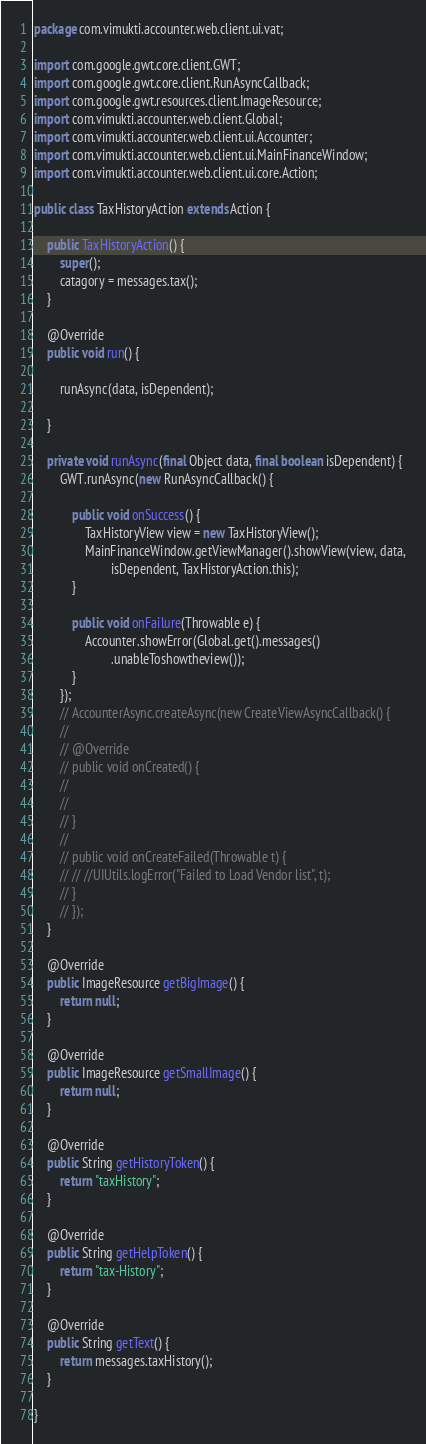<code> <loc_0><loc_0><loc_500><loc_500><_Java_>package com.vimukti.accounter.web.client.ui.vat;

import com.google.gwt.core.client.GWT;
import com.google.gwt.core.client.RunAsyncCallback;
import com.google.gwt.resources.client.ImageResource;
import com.vimukti.accounter.web.client.Global;
import com.vimukti.accounter.web.client.ui.Accounter;
import com.vimukti.accounter.web.client.ui.MainFinanceWindow;
import com.vimukti.accounter.web.client.ui.core.Action;

public class TaxHistoryAction extends Action {

	public TaxHistoryAction() {
		super();
		catagory = messages.tax();
	}

	@Override
	public void run() {

		runAsync(data, isDependent);

	}

	private void runAsync(final Object data, final boolean isDependent) {
		GWT.runAsync(new RunAsyncCallback() {

			public void onSuccess() {
				TaxHistoryView view = new TaxHistoryView();
				MainFinanceWindow.getViewManager().showView(view, data,
						isDependent, TaxHistoryAction.this);
			}

			public void onFailure(Throwable e) {
				Accounter.showError(Global.get().messages()
						.unableToshowtheview());
			}
		});
		// AccounterAsync.createAsync(new CreateViewAsyncCallback() {
		//
		// @Override
		// public void onCreated() {
		//
		//
		// }
		//
		// public void onCreateFailed(Throwable t) {
		// // //UIUtils.logError("Failed to Load Vendor list", t);
		// }
		// });
	}

	@Override
	public ImageResource getBigImage() {
		return null;
	}

	@Override
	public ImageResource getSmallImage() {
		return null;
	}

	@Override
	public String getHistoryToken() {
		return "taxHistory";
	}

	@Override
	public String getHelpToken() {
		return "tax-History";
	}

	@Override
	public String getText() {
		return messages.taxHistory();
	}

}
</code> 